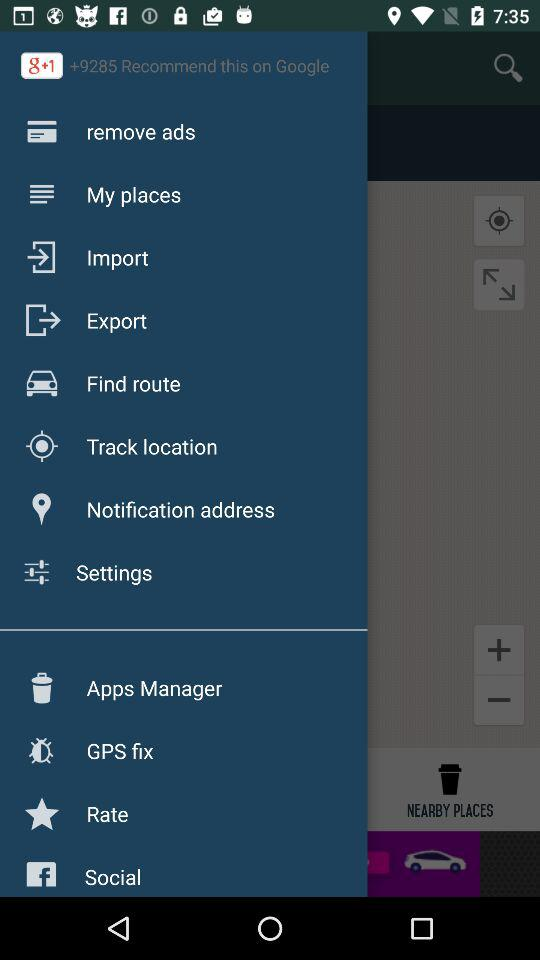How many users recommended the application on "Google"? The number of users who recommended the application is more than 9285. 